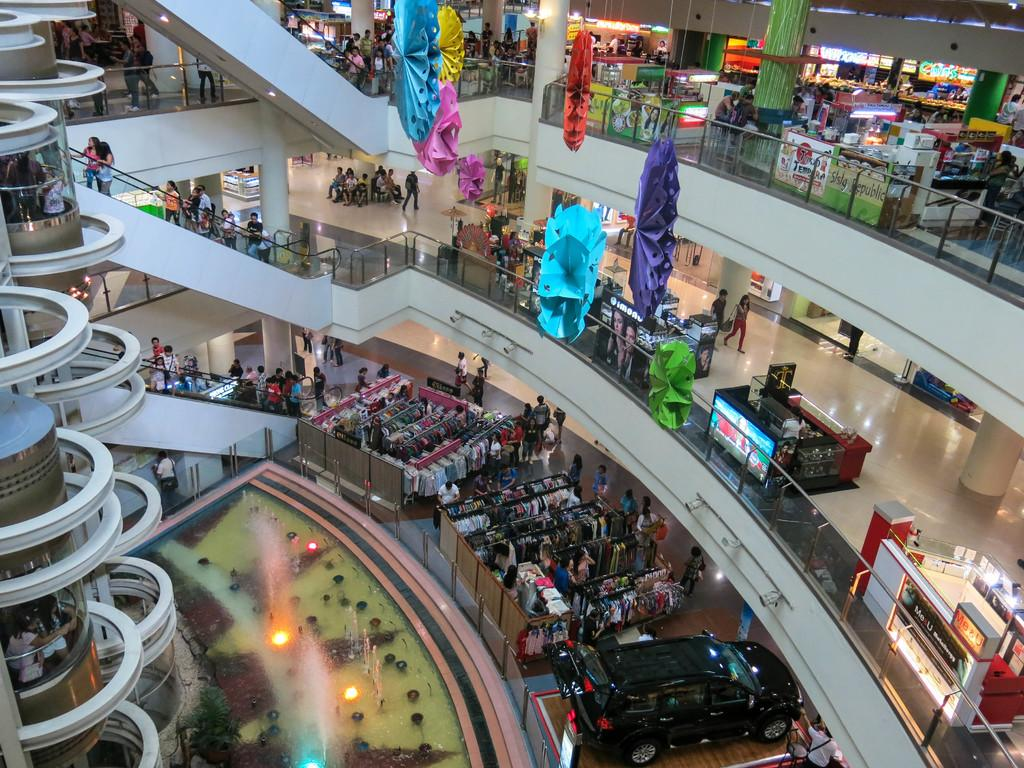What type of location is depicted in the image? The image shows an inside view of a building. Can you describe the people in the image? There are people in the image, but their specific actions or appearances are not mentioned in the facts. What items related to clothing can be seen in the image? Clothes are visible in the image, but their specific types or styles are not mentioned in the facts. What mode of transportation is present in the image? A vehicle is present in the image, but its specific type or model is not mentioned in the facts. What type of display device is visible in the image? There is a screen in the image, but its specific purpose or content is not mentioned in the facts. What type of decorative items are present in the image? Posters are present in the image, but their specific content or design is not mentioned in the facts. What type of structural support can be seen in the image? Pillars are visible in the image, but their specific number or location is not mentioned in the facts. What type of transportation device is present in the image? Lifts are present in the image, but their specific number or location is not mentioned in the facts. What type of moving staircase is visible in the image? Escalators are visible in the image, but their specific number or location is not mentioned in the facts. What type of enclosure can be seen in the image? There are walls in the image, but their specific number or location is not mentioned in the facts. What type of illumination is present in the image? Lights are present in the image, but their specific number or location is not mentioned in the facts. What unspecified objects are present in the image? There are some unspecified objects in the image, but their specific types or locations are not mentioned in the facts. What type of cord is used to connect the list to the sponge in the image? There is no mention of a list, sponge, or cord in the image or the provided facts. 